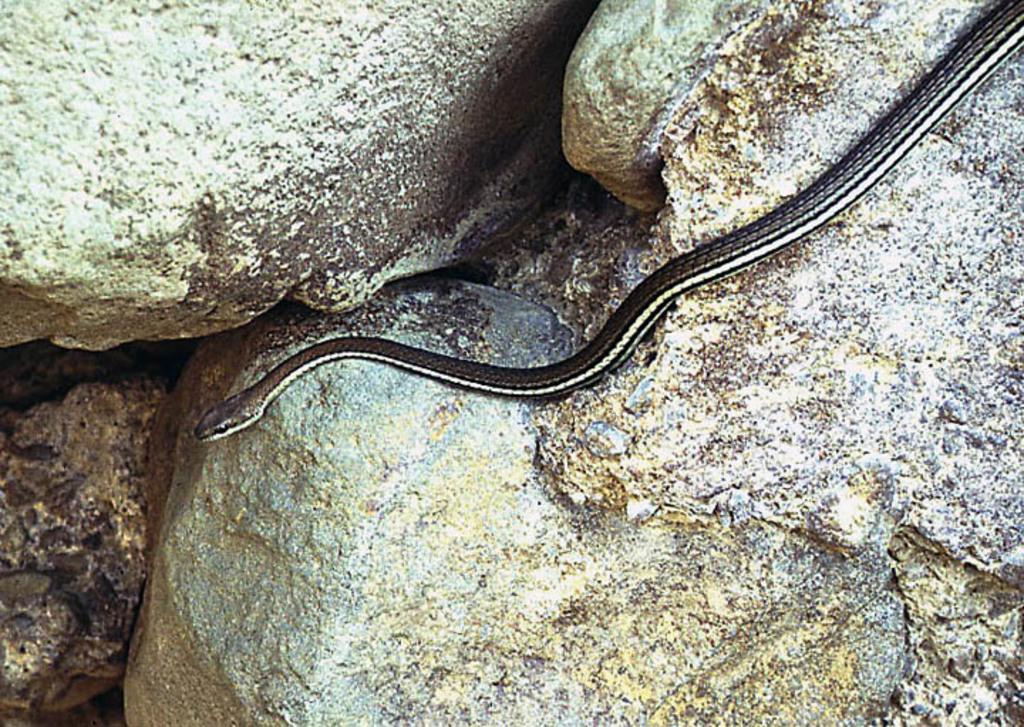Please provide a concise description of this image. In this image there is a snake crawling on the rock. In the background there are rocks. 